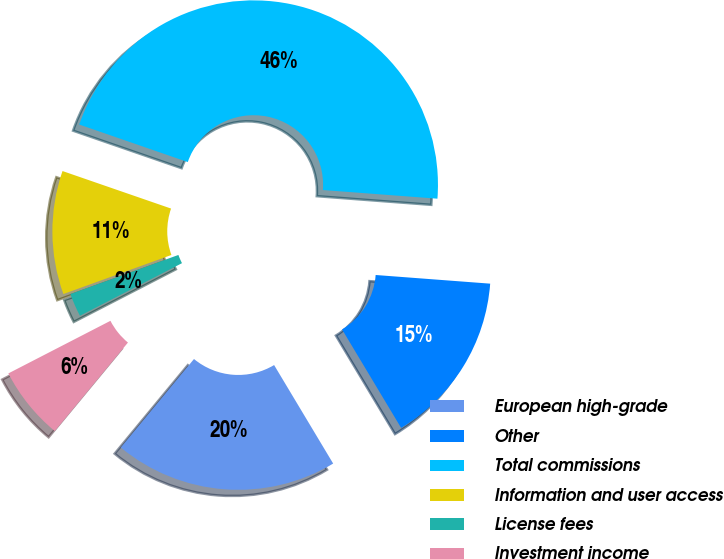<chart> <loc_0><loc_0><loc_500><loc_500><pie_chart><fcel>European high-grade<fcel>Other<fcel>Total commissions<fcel>Information and user access<fcel>License fees<fcel>Investment income<nl><fcel>19.59%<fcel>15.2%<fcel>45.9%<fcel>10.82%<fcel>2.05%<fcel>6.43%<nl></chart> 